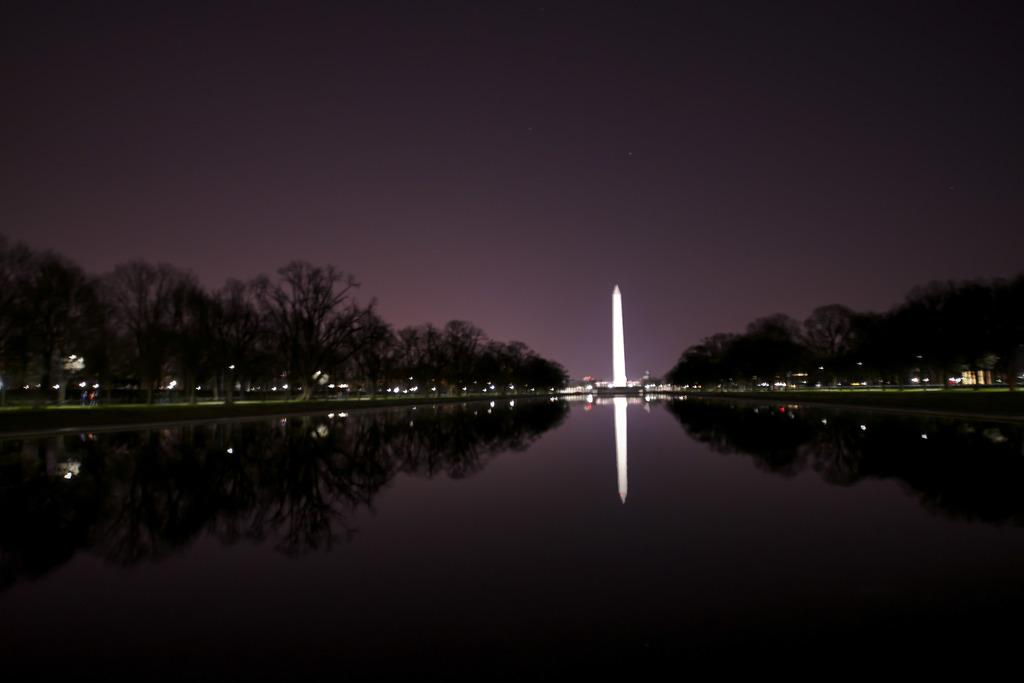What is the main subject in the center of the image? There is water in the center of the image. What can be seen in the background of the image? There is a tower and trees in the background of the image. What is visible at the top of the image? The sky is visible at the top of the image. How many plates are stacked on the dock in the image? There is no dock or plates present in the image. What type of sticks are being used to stir the water in the image? There are no sticks or stirring activity present in the image. 